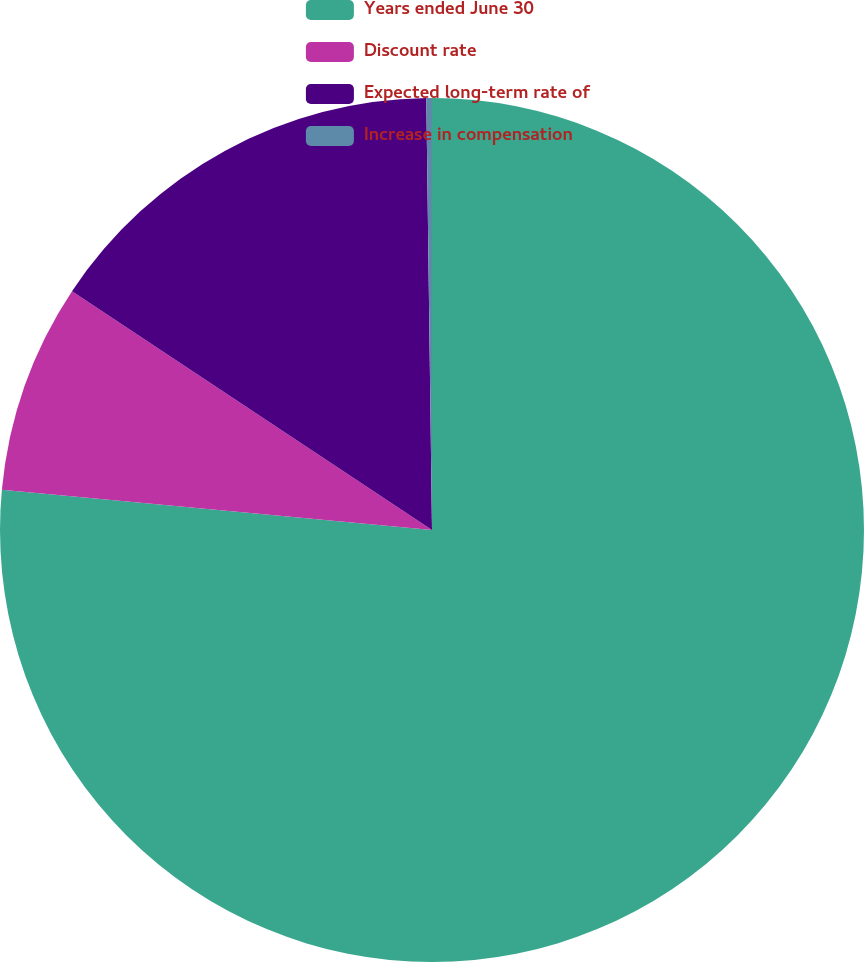Convert chart. <chart><loc_0><loc_0><loc_500><loc_500><pie_chart><fcel>Years ended June 30<fcel>Discount rate<fcel>Expected long-term rate of<fcel>Increase in compensation<nl><fcel>76.49%<fcel>7.84%<fcel>15.47%<fcel>0.21%<nl></chart> 